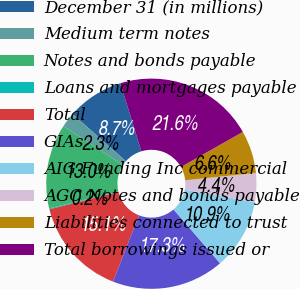Convert chart to OTSL. <chart><loc_0><loc_0><loc_500><loc_500><pie_chart><fcel>December 31 (in millions)<fcel>Medium term notes<fcel>Notes and bonds payable<fcel>Loans and mortgages payable<fcel>Total<fcel>GIAs<fcel>AIG Funding Inc commercial<fcel>AGC Notes and bonds payable<fcel>Liabilities connected to trust<fcel>Total borrowings issued or<nl><fcel>8.71%<fcel>2.29%<fcel>13.0%<fcel>0.15%<fcel>15.14%<fcel>17.28%<fcel>10.86%<fcel>4.43%<fcel>6.57%<fcel>21.57%<nl></chart> 